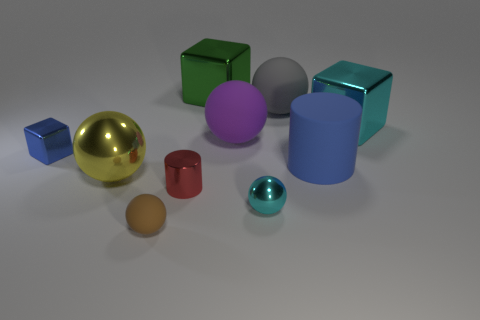Subtract all big metallic spheres. How many spheres are left? 4 Subtract all yellow balls. How many balls are left? 4 Subtract all green spheres. Subtract all red cylinders. How many spheres are left? 5 Subtract all cubes. How many objects are left? 7 Add 4 tiny things. How many tiny things are left? 8 Add 1 large metal things. How many large metal things exist? 4 Subtract 0 purple blocks. How many objects are left? 10 Subtract all small cylinders. Subtract all blue metallic things. How many objects are left? 8 